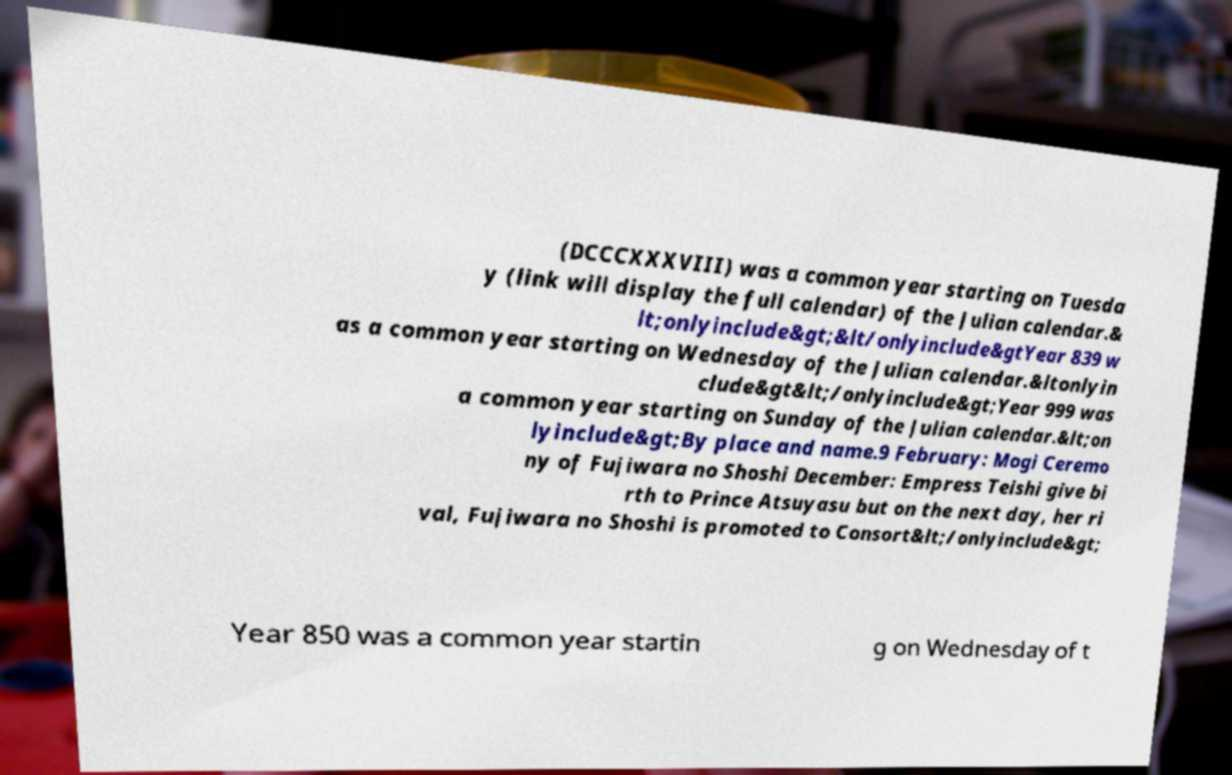Could you assist in decoding the text presented in this image and type it out clearly? (DCCCXXXVIII) was a common year starting on Tuesda y (link will display the full calendar) of the Julian calendar.& lt;onlyinclude&gt;&lt/onlyinclude&gtYear 839 w as a common year starting on Wednesday of the Julian calendar.&ltonlyin clude&gt&lt;/onlyinclude&gt;Year 999 was a common year starting on Sunday of the Julian calendar.&lt;on lyinclude&gt;By place and name.9 February: Mogi Ceremo ny of Fujiwara no Shoshi December: Empress Teishi give bi rth to Prince Atsuyasu but on the next day, her ri val, Fujiwara no Shoshi is promoted to Consort&lt;/onlyinclude&gt; Year 850 was a common year startin g on Wednesday of t 